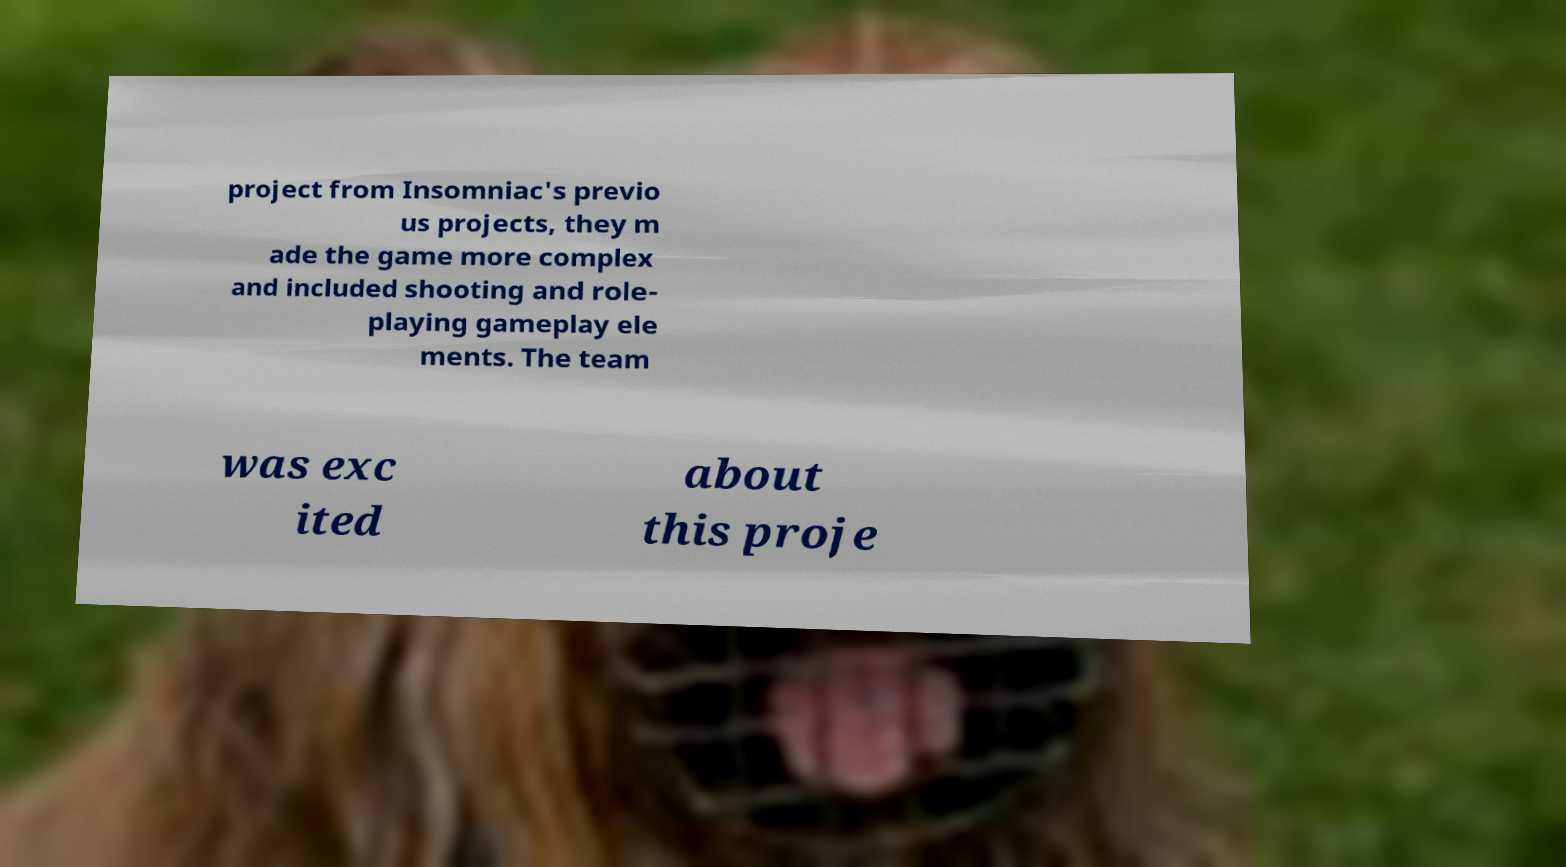What messages or text are displayed in this image? I need them in a readable, typed format. project from Insomniac's previo us projects, they m ade the game more complex and included shooting and role- playing gameplay ele ments. The team was exc ited about this proje 